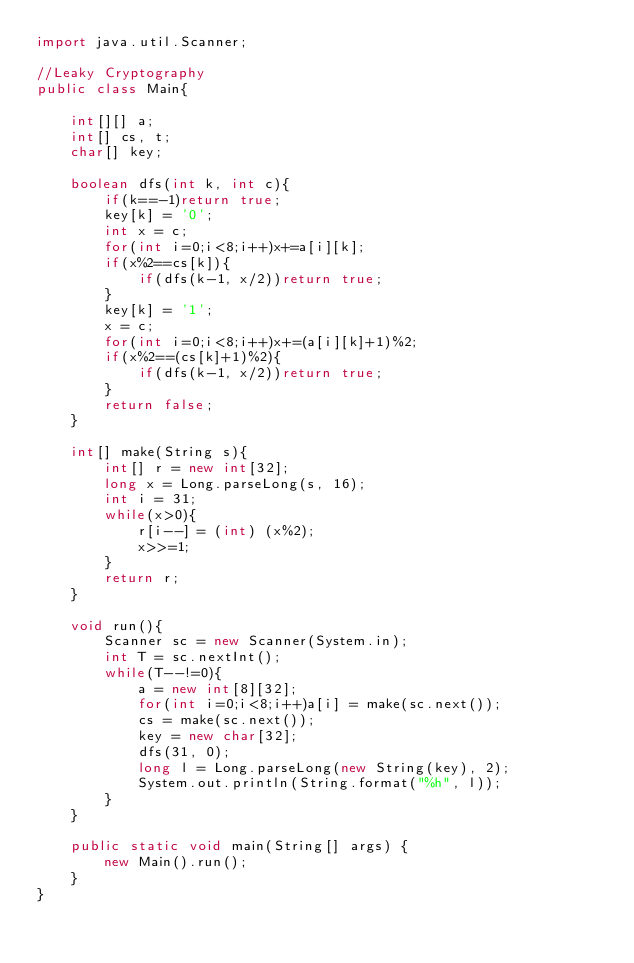Convert code to text. <code><loc_0><loc_0><loc_500><loc_500><_Java_>import java.util.Scanner;

//Leaky Cryptography
public class Main{

	int[][] a;
	int[] cs, t;
	char[] key;
	
	boolean dfs(int k, int c){
		if(k==-1)return true;
		key[k] = '0';
		int x = c;
		for(int i=0;i<8;i++)x+=a[i][k];
		if(x%2==cs[k]){
			if(dfs(k-1, x/2))return true;
		}
		key[k] = '1';
		x = c;
		for(int i=0;i<8;i++)x+=(a[i][k]+1)%2;
		if(x%2==(cs[k]+1)%2){
			if(dfs(k-1, x/2))return true;
		}
		return false;
	}
	
	int[] make(String s){
		int[] r = new int[32];
		long x = Long.parseLong(s, 16);
		int i = 31;
		while(x>0){
			r[i--] = (int) (x%2);
			x>>=1;
		}
		return r;
	}
	
	void run(){
		Scanner sc = new Scanner(System.in);
		int T = sc.nextInt();
		while(T--!=0){
			a = new int[8][32];
			for(int i=0;i<8;i++)a[i] = make(sc.next());
			cs = make(sc.next());
			key = new char[32];
			dfs(31, 0);
			long l = Long.parseLong(new String(key), 2);
			System.out.println(String.format("%h", l));
		}
	}
	
	public static void main(String[] args) {
		new Main().run();
	}
}</code> 